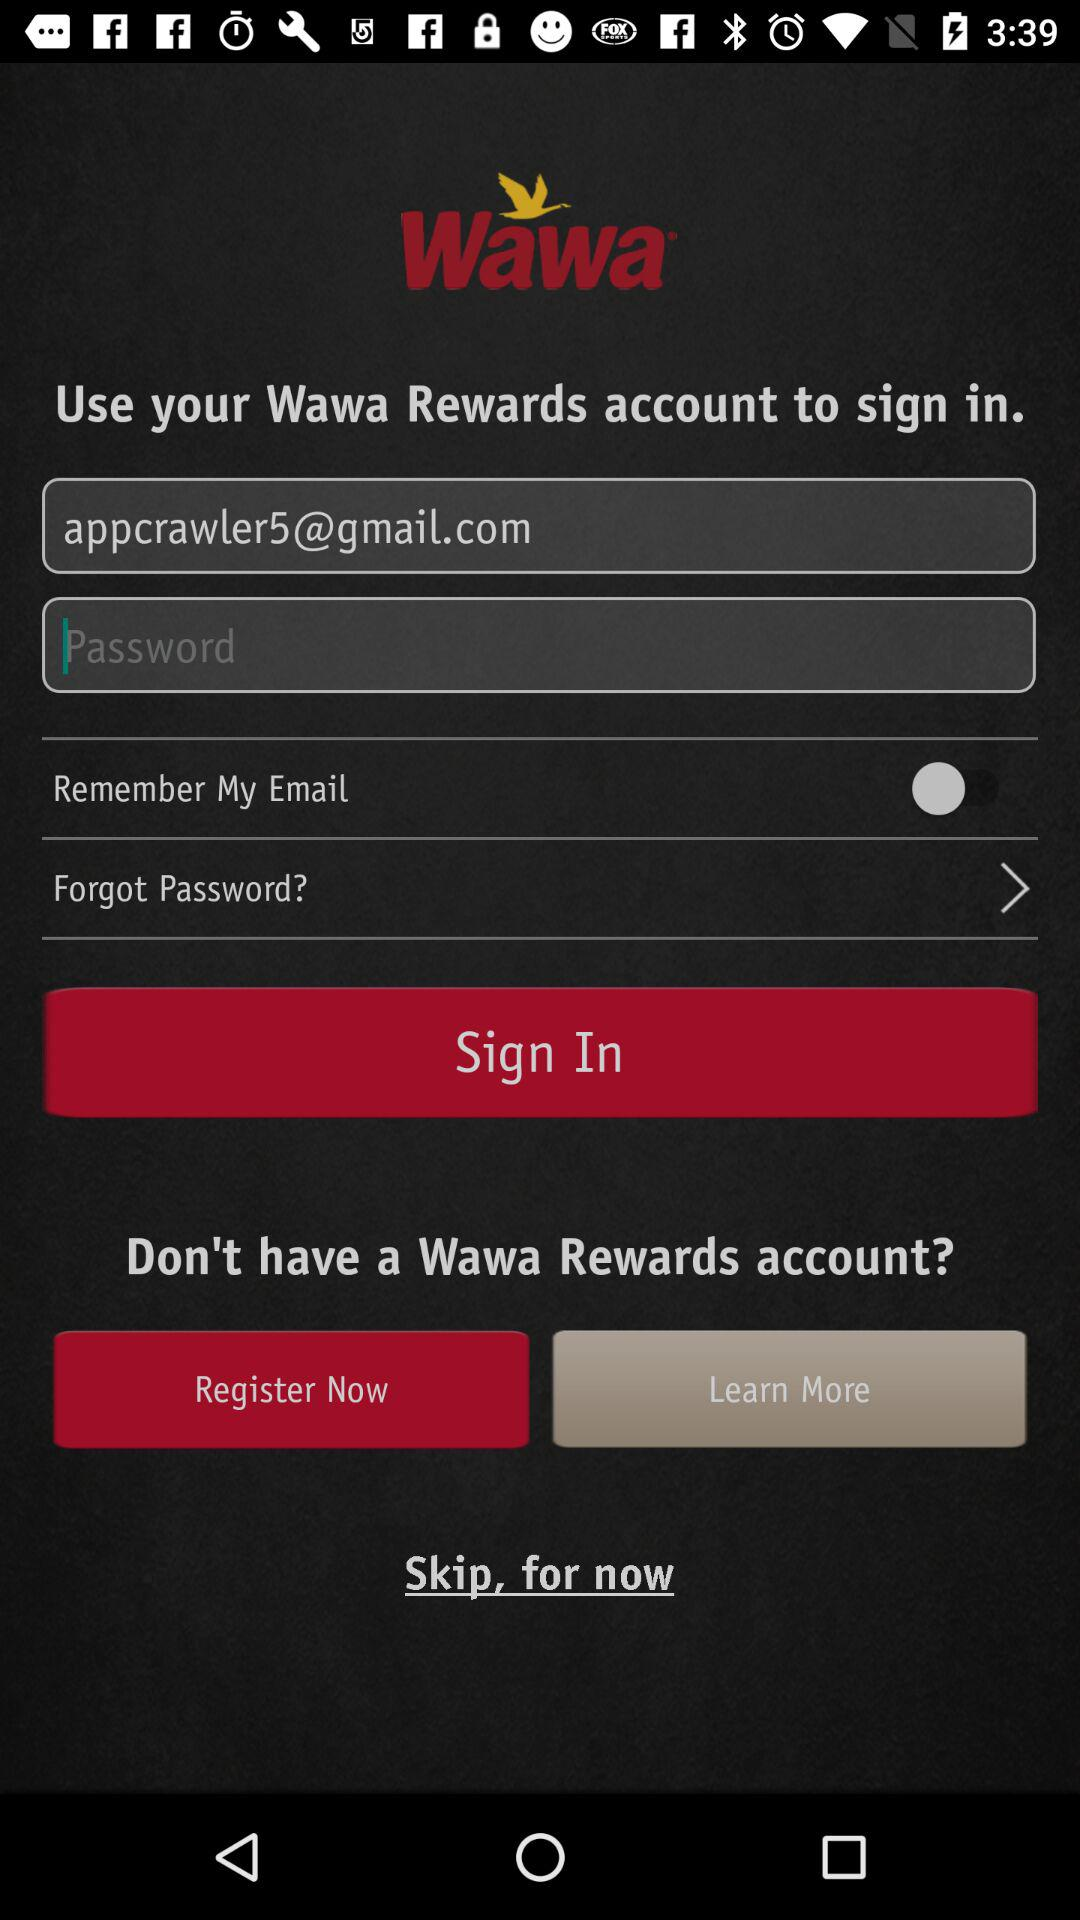What is the application name? The application name is "Wawa". 